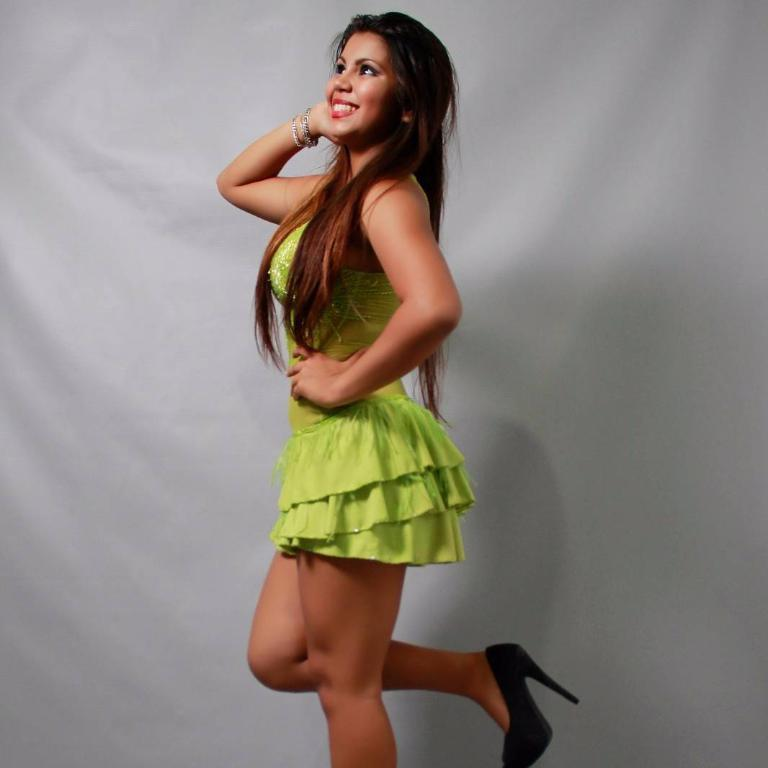Who is the main subject in the image? There is a girl in the center of the image. What can be seen in the background of the image? There is a white color cloth in the background of the image. How does the girl increase her productivity in the image? There is no indication in the image that the girl is trying to increase her productivity or that she is a laborer. 